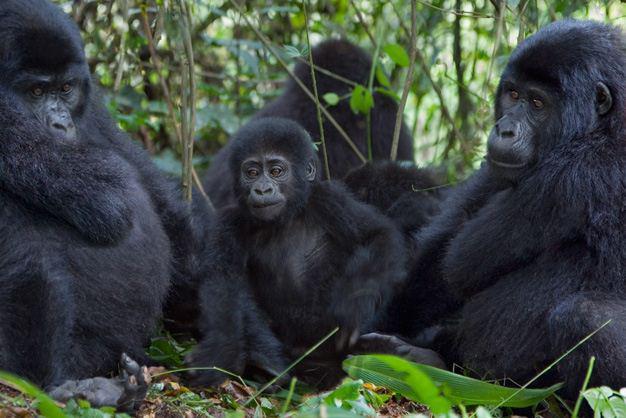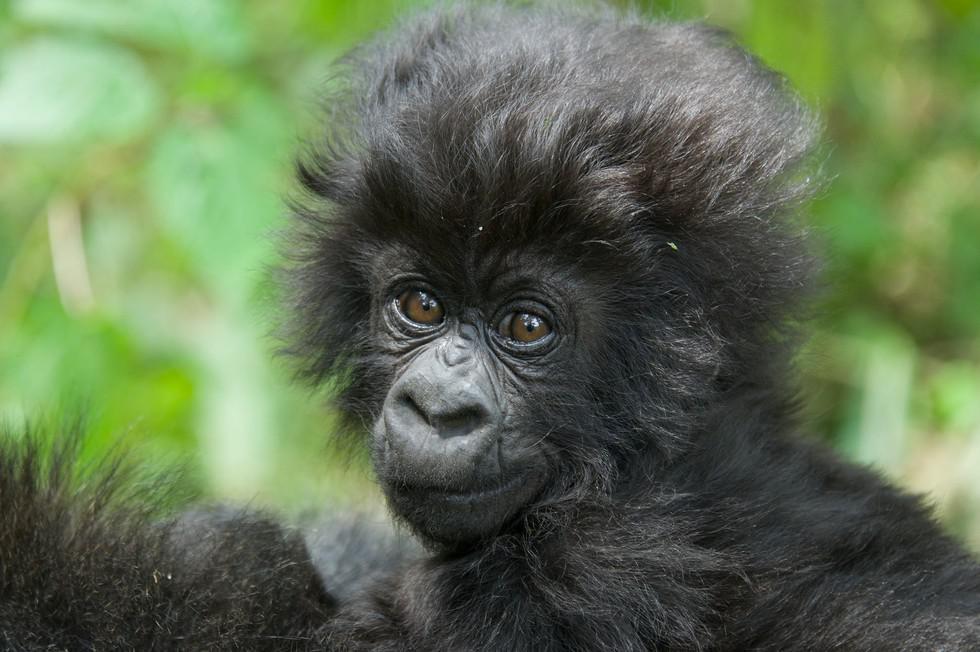The first image is the image on the left, the second image is the image on the right. For the images displayed, is the sentence "In at least one image there are two gorilla one adult holding a single baby." factually correct? Answer yes or no. No. The first image is the image on the left, the second image is the image on the right. Examine the images to the left and right. Is the description "There are exactly three gorillas." accurate? Answer yes or no. No. 